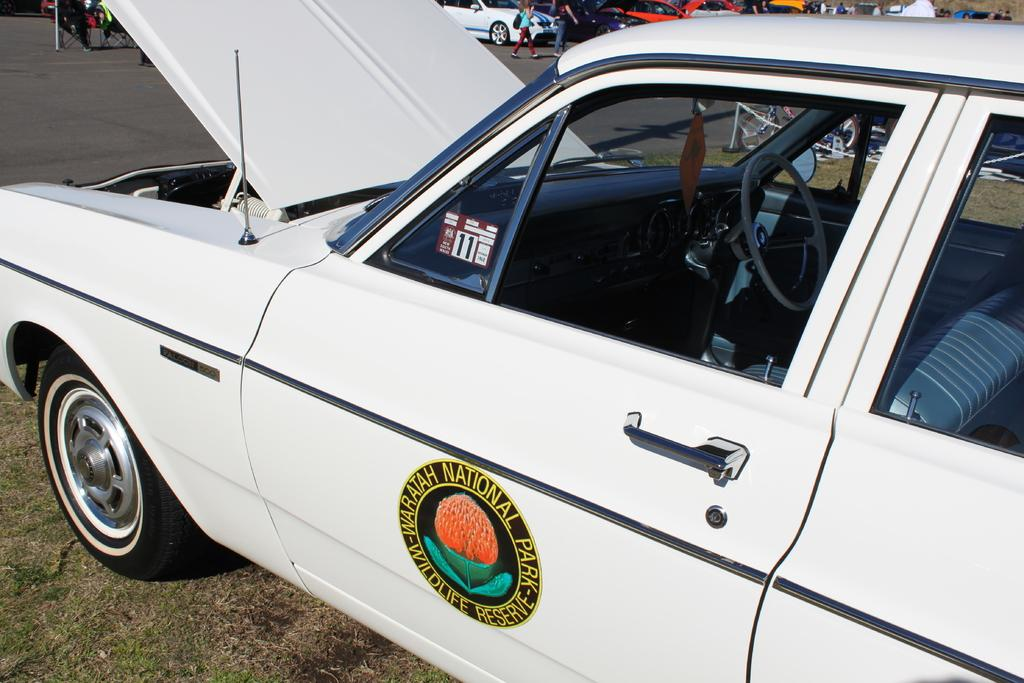What is the main subject of the image? The main subject of the image is a car. Can you describe any specific features of the car? Yes, the car has a logo on it. Are there any people visible in the image? Yes, there are people visible at the top of the image. What else can be seen in the image besides the car and people? There are other cars on the road in the image. What type of throne is depicted in the image? There is no throne present in the image; it features a car and people. What historical event is being commemorated in the image? There is no historical event being commemorated in the image; it is a scene of a car and people on the road. 